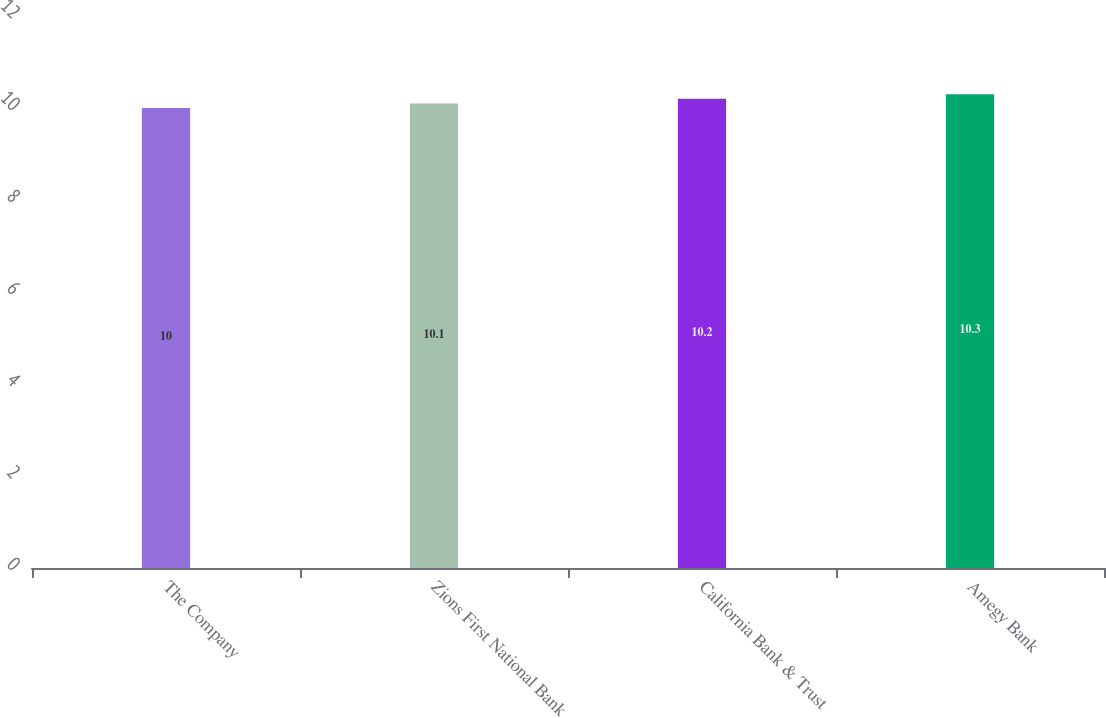Convert chart. <chart><loc_0><loc_0><loc_500><loc_500><bar_chart><fcel>The Company<fcel>Zions First National Bank<fcel>California Bank & Trust<fcel>Amegy Bank<nl><fcel>10<fcel>10.1<fcel>10.2<fcel>10.3<nl></chart> 